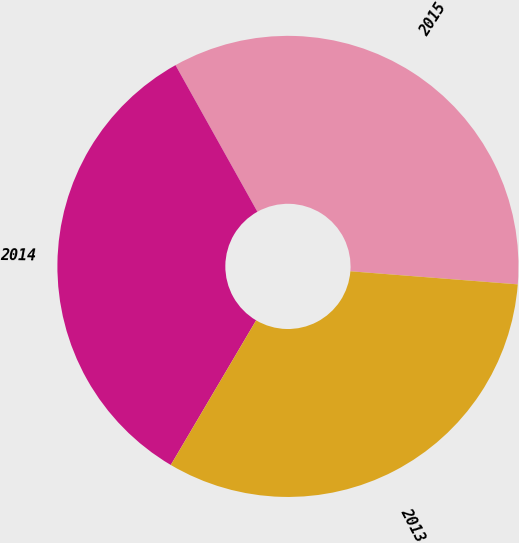Convert chart to OTSL. <chart><loc_0><loc_0><loc_500><loc_500><pie_chart><fcel>2015<fcel>2014<fcel>2013<nl><fcel>34.35%<fcel>33.41%<fcel>32.24%<nl></chart> 